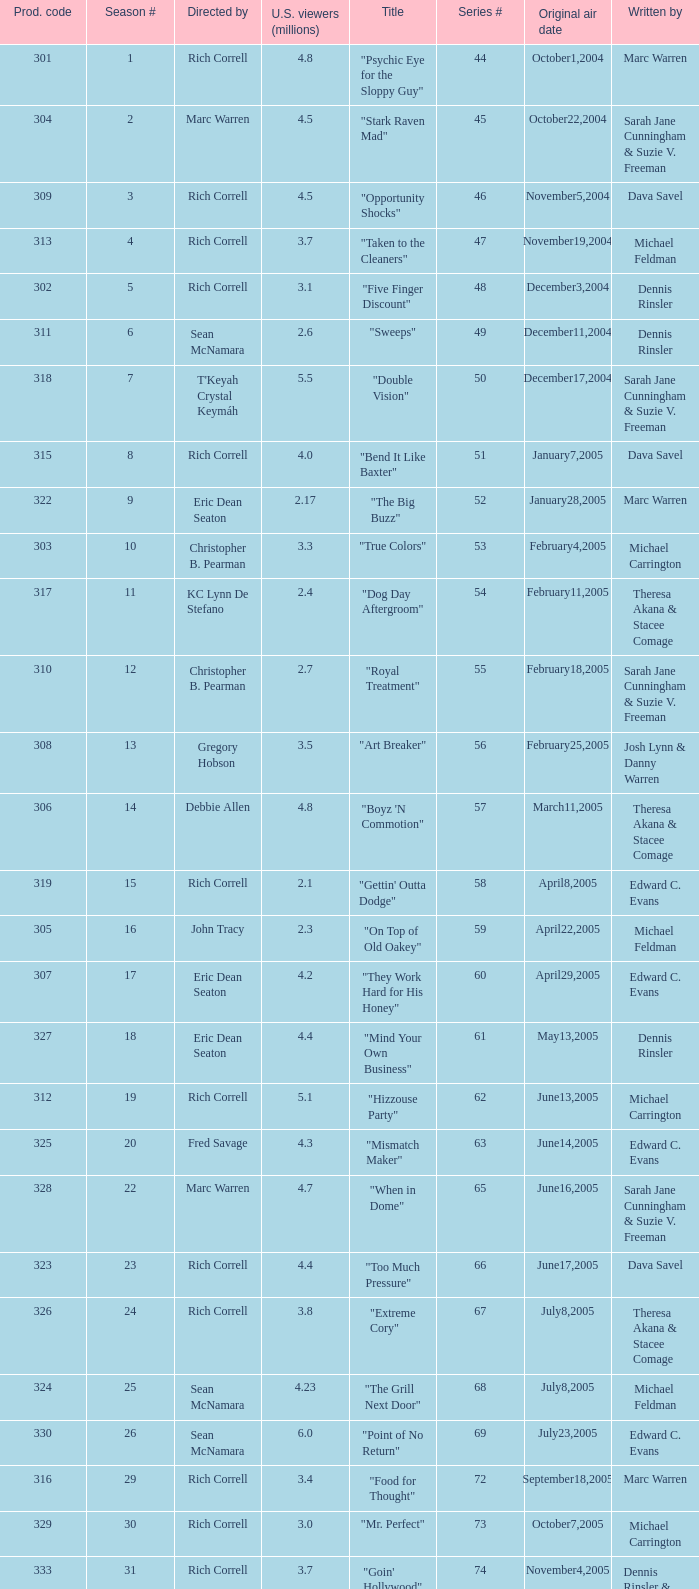What is the title of the episode directed by Rich Correll and written by Dennis Rinsler? "Five Finger Discount". Could you parse the entire table? {'header': ['Prod. code', 'Season #', 'Directed by', 'U.S. viewers (millions)', 'Title', 'Series #', 'Original air date', 'Written by'], 'rows': [['301', '1', 'Rich Correll', '4.8', '"Psychic Eye for the Sloppy Guy"', '44', 'October1,2004', 'Marc Warren'], ['304', '2', 'Marc Warren', '4.5', '"Stark Raven Mad"', '45', 'October22,2004', 'Sarah Jane Cunningham & Suzie V. Freeman'], ['309', '3', 'Rich Correll', '4.5', '"Opportunity Shocks"', '46', 'November5,2004', 'Dava Savel'], ['313', '4', 'Rich Correll', '3.7', '"Taken to the Cleaners"', '47', 'November19,2004', 'Michael Feldman'], ['302', '5', 'Rich Correll', '3.1', '"Five Finger Discount"', '48', 'December3,2004', 'Dennis Rinsler'], ['311', '6', 'Sean McNamara', '2.6', '"Sweeps"', '49', 'December11,2004', 'Dennis Rinsler'], ['318', '7', "T'Keyah Crystal Keymáh", '5.5', '"Double Vision"', '50', 'December17,2004', 'Sarah Jane Cunningham & Suzie V. Freeman'], ['315', '8', 'Rich Correll', '4.0', '"Bend It Like Baxter"', '51', 'January7,2005', 'Dava Savel'], ['322', '9', 'Eric Dean Seaton', '2.17', '"The Big Buzz"', '52', 'January28,2005', 'Marc Warren'], ['303', '10', 'Christopher B. Pearman', '3.3', '"True Colors"', '53', 'February4,2005', 'Michael Carrington'], ['317', '11', 'KC Lynn De Stefano', '2.4', '"Dog Day Aftergroom"', '54', 'February11,2005', 'Theresa Akana & Stacee Comage'], ['310', '12', 'Christopher B. Pearman', '2.7', '"Royal Treatment"', '55', 'February18,2005', 'Sarah Jane Cunningham & Suzie V. Freeman'], ['308', '13', 'Gregory Hobson', '3.5', '"Art Breaker"', '56', 'February25,2005', 'Josh Lynn & Danny Warren'], ['306', '14', 'Debbie Allen', '4.8', '"Boyz \'N Commotion"', '57', 'March11,2005', 'Theresa Akana & Stacee Comage'], ['319', '15', 'Rich Correll', '2.1', '"Gettin\' Outta Dodge"', '58', 'April8,2005', 'Edward C. Evans'], ['305', '16', 'John Tracy', '2.3', '"On Top of Old Oakey"', '59', 'April22,2005', 'Michael Feldman'], ['307', '17', 'Eric Dean Seaton', '4.2', '"They Work Hard for His Honey"', '60', 'April29,2005', 'Edward C. Evans'], ['327', '18', 'Eric Dean Seaton', '4.4', '"Mind Your Own Business"', '61', 'May13,2005', 'Dennis Rinsler'], ['312', '19', 'Rich Correll', '5.1', '"Hizzouse Party"', '62', 'June13,2005', 'Michael Carrington'], ['325', '20', 'Fred Savage', '4.3', '"Mismatch Maker"', '63', 'June14,2005', 'Edward C. Evans'], ['328', '22', 'Marc Warren', '4.7', '"When in Dome"', '65', 'June16,2005', 'Sarah Jane Cunningham & Suzie V. Freeman'], ['323', '23', 'Rich Correll', '4.4', '"Too Much Pressure"', '66', 'June17,2005', 'Dava Savel'], ['326', '24', 'Rich Correll', '3.8', '"Extreme Cory"', '67', 'July8,2005', 'Theresa Akana & Stacee Comage'], ['324', '25', 'Sean McNamara', '4.23', '"The Grill Next Door"', '68', 'July8,2005', 'Michael Feldman'], ['330', '26', 'Sean McNamara', '6.0', '"Point of No Return"', '69', 'July23,2005', 'Edward C. Evans'], ['316', '29', 'Rich Correll', '3.4', '"Food for Thought"', '72', 'September18,2005', 'Marc Warren'], ['329', '30', 'Rich Correll', '3.0', '"Mr. Perfect"', '73', 'October7,2005', 'Michael Carrington'], ['333', '31', 'Rich Correll', '3.7', '"Goin\' Hollywood"', '74', 'November4,2005', 'Dennis Rinsler & Marc Warren'], ['334', '32', 'Sean McNamara', '3.3', '"Save the Last Dance"', '75', 'November25,2005', 'Marc Warren'], ['332', '33', 'Rondell Sheridan', '3.6', '"Cake Fear"', '76', 'December16,2005', 'Theresa Akana & Stacee Comage'], ['335', '34', 'Marc Warren', '4.7', '"Vision Impossible"', '77', 'January6,2006', 'David Brookwell & Sean McNamara']]} 